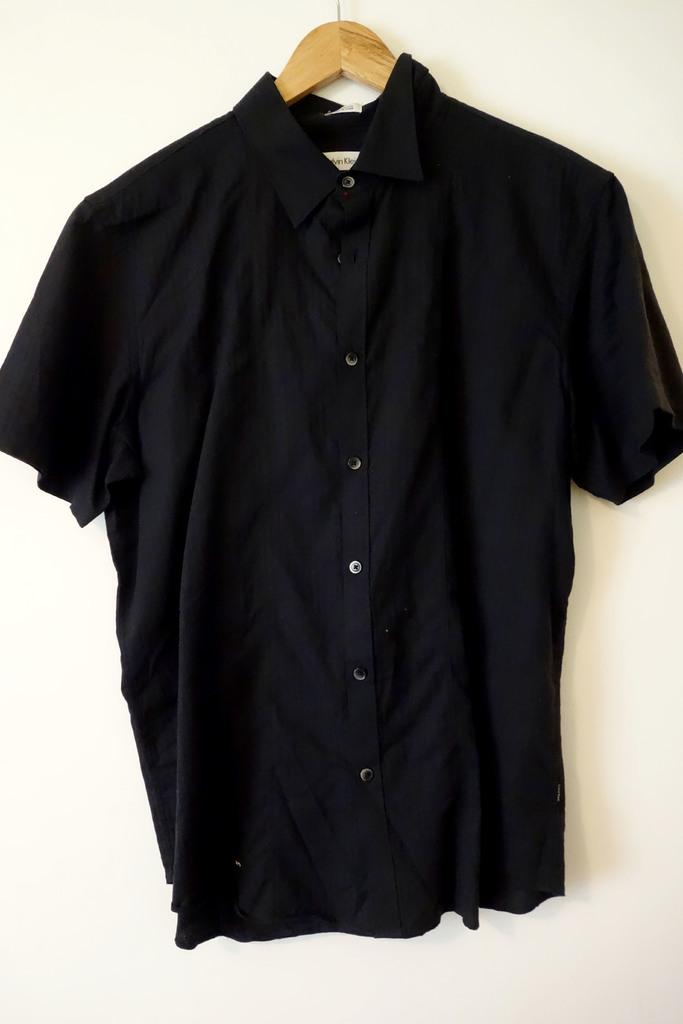What type of clothing item is hanging in the image? There is a shirt on a hanger in the image. What can be seen behind the shirt in the image? There is a wall visible in the image. What is the current condition of the nation in the image? There is no information about a nation or its condition in the image, as it only features a shirt on a hanger and a wall. 